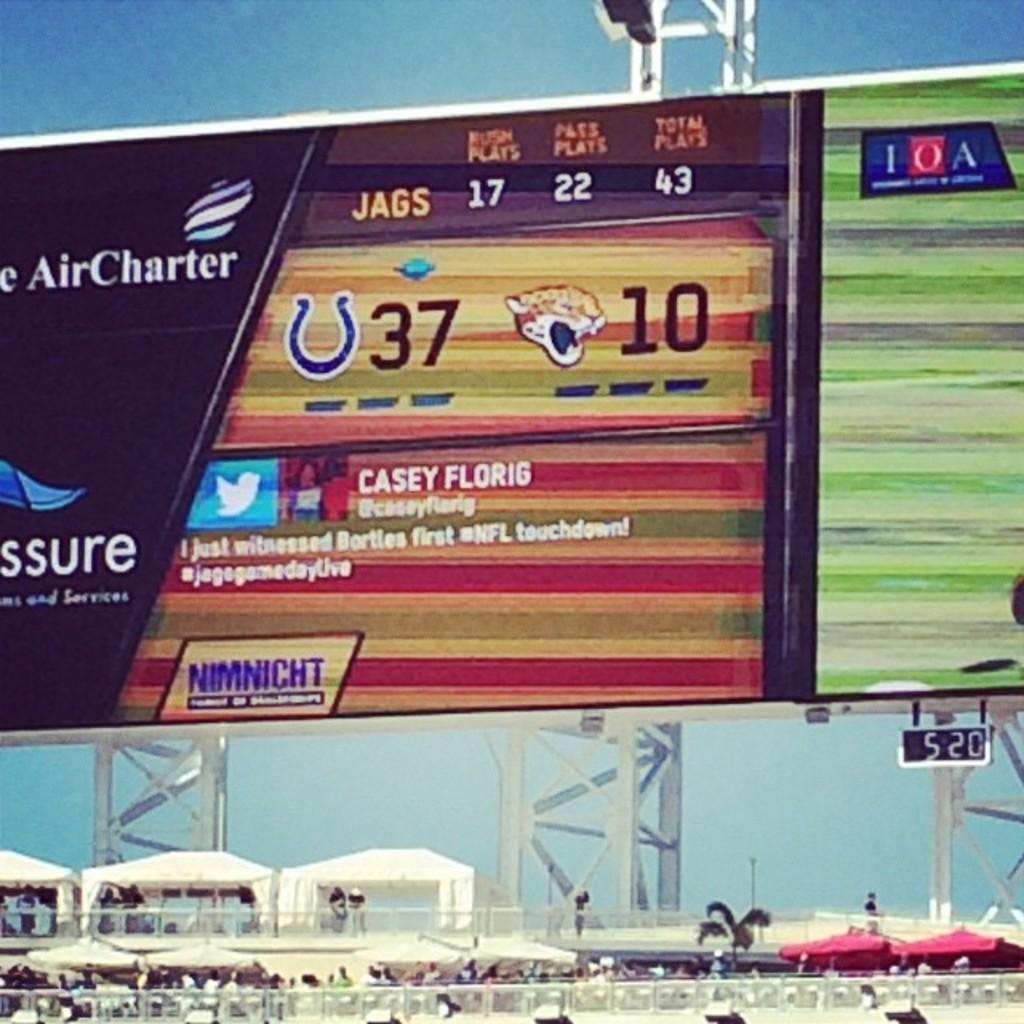<image>
Offer a succinct explanation of the picture presented. An electronic billboard displaying different advertisements and a tweet from someone named Casey Florig. 